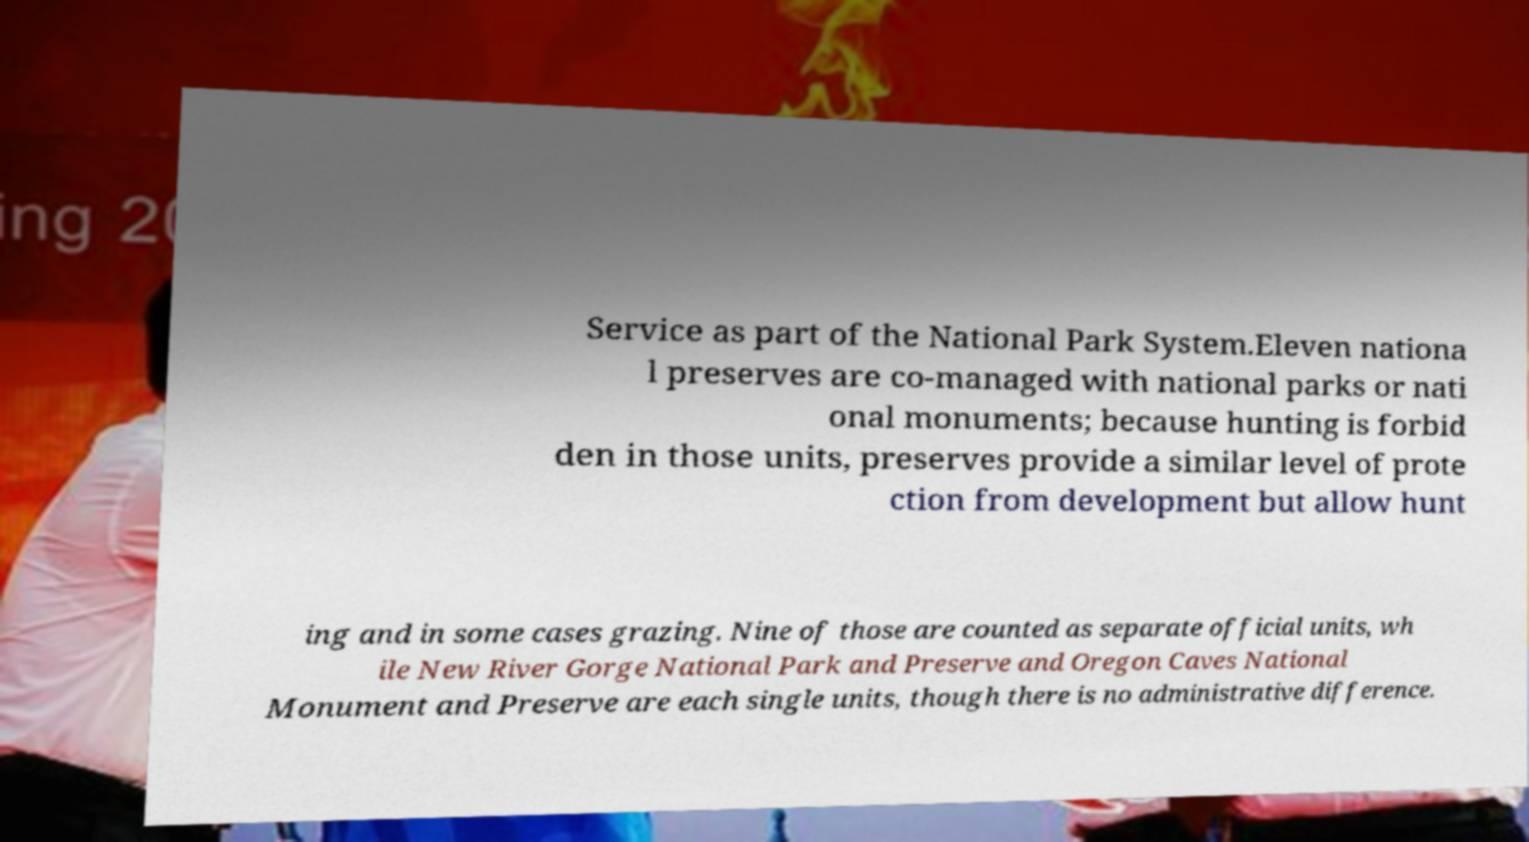Please identify and transcribe the text found in this image. Service as part of the National Park System.Eleven nationa l preserves are co-managed with national parks or nati onal monuments; because hunting is forbid den in those units, preserves provide a similar level of prote ction from development but allow hunt ing and in some cases grazing. Nine of those are counted as separate official units, wh ile New River Gorge National Park and Preserve and Oregon Caves National Monument and Preserve are each single units, though there is no administrative difference. 